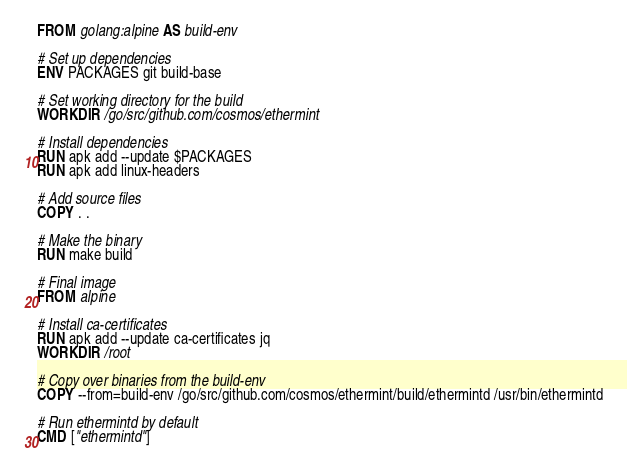<code> <loc_0><loc_0><loc_500><loc_500><_Dockerfile_>FROM golang:alpine AS build-env

# Set up dependencies
ENV PACKAGES git build-base

# Set working directory for the build
WORKDIR /go/src/github.com/cosmos/ethermint

# Install dependencies
RUN apk add --update $PACKAGES
RUN apk add linux-headers

# Add source files
COPY . .

# Make the binary
RUN make build

# Final image
FROM alpine

# Install ca-certificates
RUN apk add --update ca-certificates jq
WORKDIR /root

# Copy over binaries from the build-env
COPY --from=build-env /go/src/github.com/cosmos/ethermint/build/ethermintd /usr/bin/ethermintd

# Run ethermintd by default
CMD ["ethermintd"]
</code> 